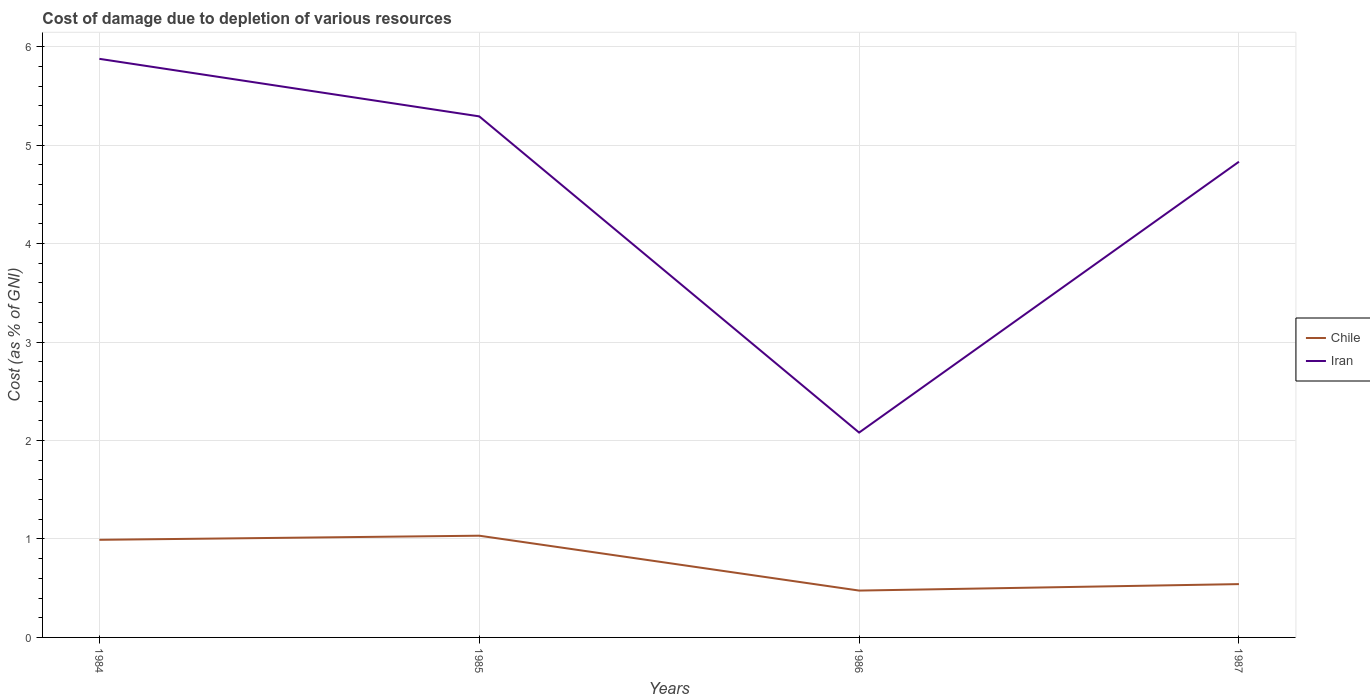How many different coloured lines are there?
Your answer should be very brief. 2. Is the number of lines equal to the number of legend labels?
Provide a succinct answer. Yes. Across all years, what is the maximum cost of damage caused due to the depletion of various resources in Iran?
Your answer should be compact. 2.08. What is the total cost of damage caused due to the depletion of various resources in Iran in the graph?
Provide a succinct answer. 0.46. What is the difference between the highest and the second highest cost of damage caused due to the depletion of various resources in Chile?
Provide a short and direct response. 0.56. What is the difference between the highest and the lowest cost of damage caused due to the depletion of various resources in Iran?
Provide a succinct answer. 3. How many lines are there?
Provide a short and direct response. 2. What is the difference between two consecutive major ticks on the Y-axis?
Provide a succinct answer. 1. Does the graph contain grids?
Offer a terse response. Yes. How many legend labels are there?
Give a very brief answer. 2. What is the title of the graph?
Your response must be concise. Cost of damage due to depletion of various resources. What is the label or title of the X-axis?
Offer a terse response. Years. What is the label or title of the Y-axis?
Your response must be concise. Cost (as % of GNI). What is the Cost (as % of GNI) in Chile in 1984?
Make the answer very short. 0.99. What is the Cost (as % of GNI) in Iran in 1984?
Your answer should be very brief. 5.88. What is the Cost (as % of GNI) of Chile in 1985?
Offer a terse response. 1.03. What is the Cost (as % of GNI) in Iran in 1985?
Keep it short and to the point. 5.29. What is the Cost (as % of GNI) of Chile in 1986?
Keep it short and to the point. 0.48. What is the Cost (as % of GNI) in Iran in 1986?
Keep it short and to the point. 2.08. What is the Cost (as % of GNI) of Chile in 1987?
Your response must be concise. 0.54. What is the Cost (as % of GNI) in Iran in 1987?
Make the answer very short. 4.83. Across all years, what is the maximum Cost (as % of GNI) of Chile?
Your response must be concise. 1.03. Across all years, what is the maximum Cost (as % of GNI) of Iran?
Offer a terse response. 5.88. Across all years, what is the minimum Cost (as % of GNI) in Chile?
Make the answer very short. 0.48. Across all years, what is the minimum Cost (as % of GNI) of Iran?
Your response must be concise. 2.08. What is the total Cost (as % of GNI) in Chile in the graph?
Your answer should be compact. 3.04. What is the total Cost (as % of GNI) of Iran in the graph?
Your answer should be compact. 18.08. What is the difference between the Cost (as % of GNI) in Chile in 1984 and that in 1985?
Keep it short and to the point. -0.04. What is the difference between the Cost (as % of GNI) of Iran in 1984 and that in 1985?
Give a very brief answer. 0.58. What is the difference between the Cost (as % of GNI) in Chile in 1984 and that in 1986?
Make the answer very short. 0.52. What is the difference between the Cost (as % of GNI) in Iran in 1984 and that in 1986?
Offer a very short reply. 3.8. What is the difference between the Cost (as % of GNI) of Chile in 1984 and that in 1987?
Provide a succinct answer. 0.45. What is the difference between the Cost (as % of GNI) in Iran in 1984 and that in 1987?
Keep it short and to the point. 1.04. What is the difference between the Cost (as % of GNI) in Chile in 1985 and that in 1986?
Ensure brevity in your answer.  0.56. What is the difference between the Cost (as % of GNI) of Iran in 1985 and that in 1986?
Your answer should be compact. 3.21. What is the difference between the Cost (as % of GNI) of Chile in 1985 and that in 1987?
Your response must be concise. 0.49. What is the difference between the Cost (as % of GNI) of Iran in 1985 and that in 1987?
Provide a succinct answer. 0.46. What is the difference between the Cost (as % of GNI) of Chile in 1986 and that in 1987?
Offer a terse response. -0.07. What is the difference between the Cost (as % of GNI) of Iran in 1986 and that in 1987?
Your response must be concise. -2.75. What is the difference between the Cost (as % of GNI) in Chile in 1984 and the Cost (as % of GNI) in Iran in 1985?
Ensure brevity in your answer.  -4.3. What is the difference between the Cost (as % of GNI) of Chile in 1984 and the Cost (as % of GNI) of Iran in 1986?
Keep it short and to the point. -1.09. What is the difference between the Cost (as % of GNI) in Chile in 1984 and the Cost (as % of GNI) in Iran in 1987?
Your answer should be very brief. -3.84. What is the difference between the Cost (as % of GNI) of Chile in 1985 and the Cost (as % of GNI) of Iran in 1986?
Ensure brevity in your answer.  -1.05. What is the difference between the Cost (as % of GNI) in Chile in 1985 and the Cost (as % of GNI) in Iran in 1987?
Provide a succinct answer. -3.8. What is the difference between the Cost (as % of GNI) in Chile in 1986 and the Cost (as % of GNI) in Iran in 1987?
Offer a terse response. -4.36. What is the average Cost (as % of GNI) of Chile per year?
Make the answer very short. 0.76. What is the average Cost (as % of GNI) of Iran per year?
Your answer should be compact. 4.52. In the year 1984, what is the difference between the Cost (as % of GNI) of Chile and Cost (as % of GNI) of Iran?
Make the answer very short. -4.89. In the year 1985, what is the difference between the Cost (as % of GNI) in Chile and Cost (as % of GNI) in Iran?
Make the answer very short. -4.26. In the year 1986, what is the difference between the Cost (as % of GNI) of Chile and Cost (as % of GNI) of Iran?
Ensure brevity in your answer.  -1.6. In the year 1987, what is the difference between the Cost (as % of GNI) in Chile and Cost (as % of GNI) in Iran?
Keep it short and to the point. -4.29. What is the ratio of the Cost (as % of GNI) in Chile in 1984 to that in 1985?
Your answer should be compact. 0.96. What is the ratio of the Cost (as % of GNI) in Iran in 1984 to that in 1985?
Give a very brief answer. 1.11. What is the ratio of the Cost (as % of GNI) in Chile in 1984 to that in 1986?
Offer a terse response. 2.08. What is the ratio of the Cost (as % of GNI) in Iran in 1984 to that in 1986?
Your response must be concise. 2.82. What is the ratio of the Cost (as % of GNI) in Chile in 1984 to that in 1987?
Ensure brevity in your answer.  1.83. What is the ratio of the Cost (as % of GNI) of Iran in 1984 to that in 1987?
Give a very brief answer. 1.22. What is the ratio of the Cost (as % of GNI) of Chile in 1985 to that in 1986?
Give a very brief answer. 2.17. What is the ratio of the Cost (as % of GNI) in Iran in 1985 to that in 1986?
Provide a short and direct response. 2.54. What is the ratio of the Cost (as % of GNI) in Chile in 1985 to that in 1987?
Provide a short and direct response. 1.91. What is the ratio of the Cost (as % of GNI) in Iran in 1985 to that in 1987?
Offer a very short reply. 1.1. What is the ratio of the Cost (as % of GNI) of Chile in 1986 to that in 1987?
Give a very brief answer. 0.88. What is the ratio of the Cost (as % of GNI) in Iran in 1986 to that in 1987?
Keep it short and to the point. 0.43. What is the difference between the highest and the second highest Cost (as % of GNI) of Chile?
Make the answer very short. 0.04. What is the difference between the highest and the second highest Cost (as % of GNI) in Iran?
Keep it short and to the point. 0.58. What is the difference between the highest and the lowest Cost (as % of GNI) in Chile?
Provide a succinct answer. 0.56. What is the difference between the highest and the lowest Cost (as % of GNI) in Iran?
Offer a terse response. 3.8. 